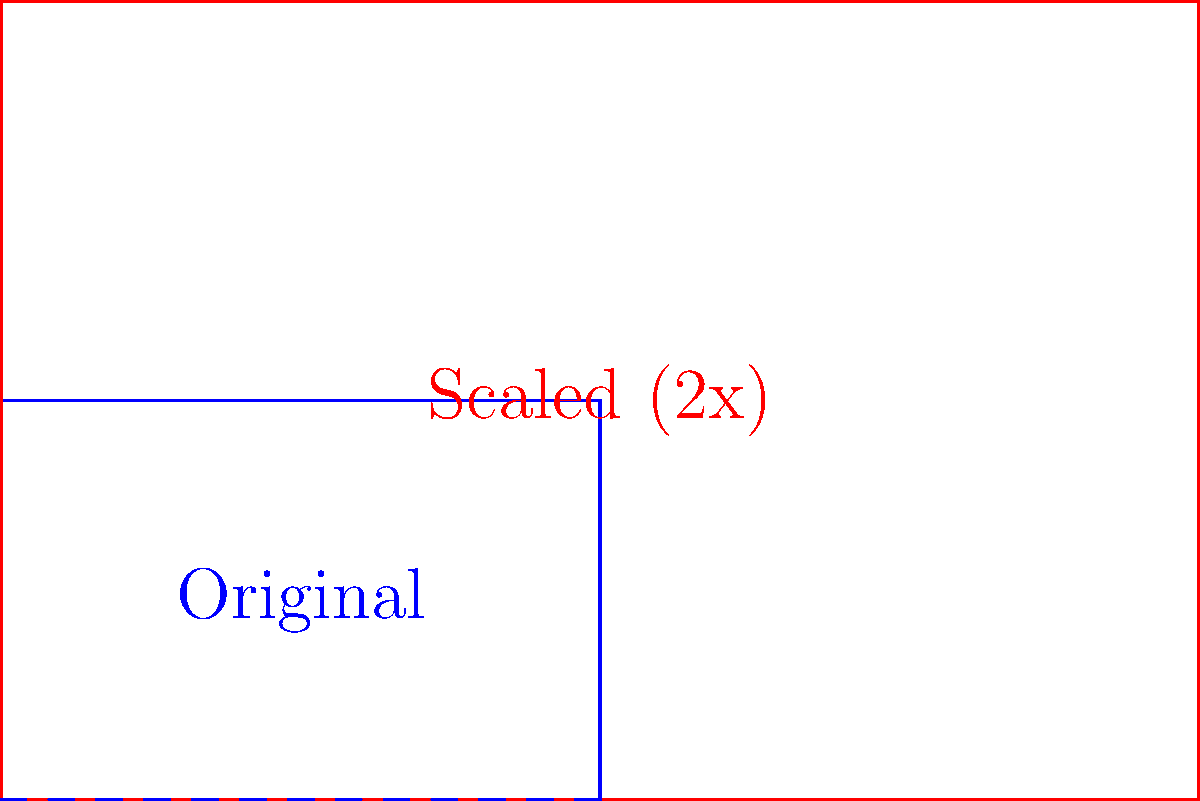In your final year of college, you're revisiting key concepts from your geometry classes. Consider the blue rectangle in the diagram, which represents the original shape. If this rectangle is scaled by a factor of 2 (as shown by the red rectangle), how does the area of the new shape compare to the area of the original? Express your answer as a ratio of new area to original area. Let's approach this step-by-step:

1) First, let's consider what scaling by a factor of 2 means:
   - Each dimension (length and width) of the original shape is multiplied by 2.

2) Let's denote the original dimensions:
   - Length = $l$
   - Width = $w$

3) The dimensions of the scaled shape will be:
   - New length = $2l$
   - New width = $2w$

4) Now, let's compare the areas:
   - Original area = $l \times w = lw$
   - New area = $2l \times 2w = 4lw$

5) To express this as a ratio:
   $\frac{\text{New Area}}{\text{Original Area}} = \frac{4lw}{lw} = 4$

6) This means the new area is 4 times the original area.

The key insight here is that when we scale a two-dimensional shape, the area increases by the square of the scale factor. In this case, $2^2 = 4$.
Answer: $4:1$ or $4$ 